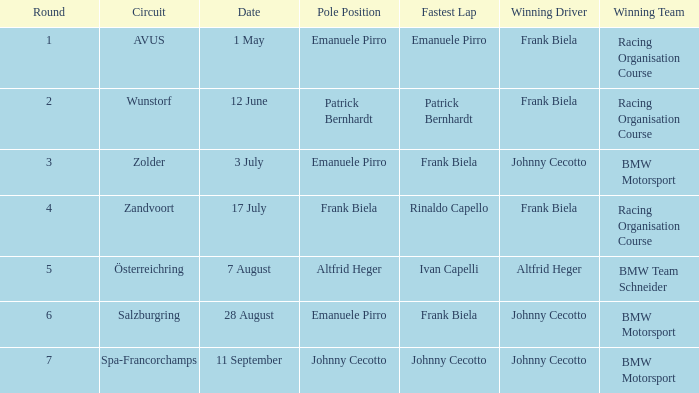Who secured the top spot in round 7? Johnny Cecotto. 